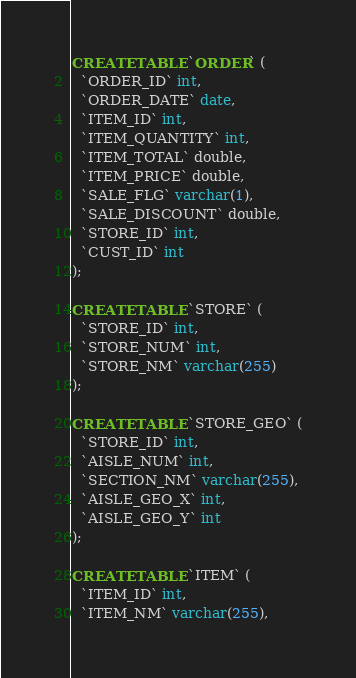<code> <loc_0><loc_0><loc_500><loc_500><_SQL_>CREATE TABLE `ORDER` (
  `ORDER_ID` int,
  `ORDER_DATE` date,
  `ITEM_ID` int,
  `ITEM_QUANTITY` int,
  `ITEM_TOTAL` double,
  `ITEM_PRICE` double,
  `SALE_FLG` varchar(1),
  `SALE_DISCOUNT` double,
  `STORE_ID` int,
  `CUST_ID` int
);

CREATE TABLE `STORE` (
  `STORE_ID` int,
  `STORE_NUM` int,
  `STORE_NM` varchar(255)
);

CREATE TABLE `STORE_GEO` (
  `STORE_ID` int,
  `AISLE_NUM` int,
  `SECTION_NM` varchar(255),
  `AISLE_GEO_X` int,
  `AISLE_GEO_Y` int
);

CREATE TABLE `ITEM` (
  `ITEM_ID` int,
  `ITEM_NM` varchar(255),</code> 